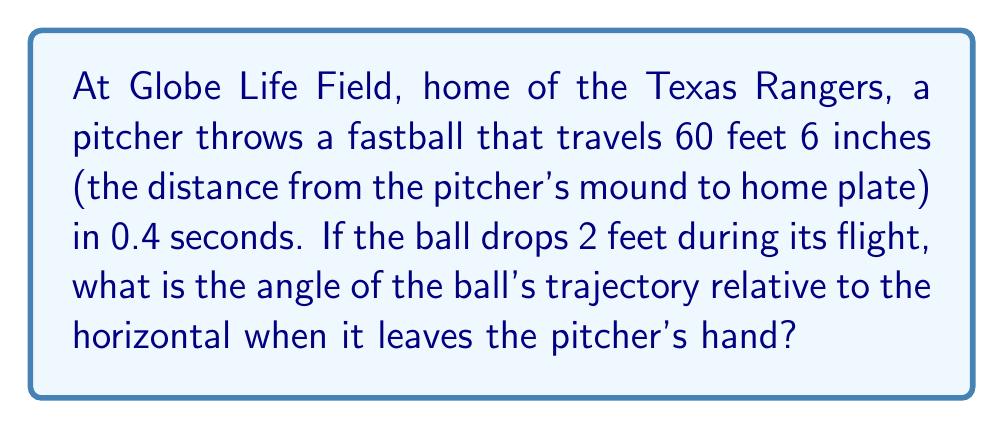Give your solution to this math problem. Let's approach this step-by-step:

1) First, we need to set up our coordinate system. Let's use the horizontal distance as x and the vertical drop as y.

2) We know:
   - Horizontal distance (x) = 60.5 feet
   - Time (t) = 0.4 seconds
   - Vertical drop (y) = 2 feet

3) We can use the equation of motion for an object under constant acceleration:

   $$y = y_0 + v_0y * t - \frac{1}{2}gt^2$$

   Where:
   $y_0$ is the initial height (0 in this case)
   $v_0y$ is the initial vertical velocity
   $g$ is the acceleration due to gravity (32 ft/s^2)

4) Substituting our values:

   $$-2 = 0 + v_0y * 0.4 - \frac{1}{2} * 32 * 0.4^2$$

5) Simplify:

   $$-2 = 0.4v_0y - 2.56$$

6) Solve for $v_0y$:

   $$0.4v_0y = 0.56$$
   $$v_0y = 1.4 \text{ ft/s}$$

7) Now we know the vertical component of the initial velocity. For the horizontal component:

   $$v_0x = \frac{60.5 \text{ ft}}{0.4 \text{ s}} = 151.25 \text{ ft/s}$$

8) The angle θ can be found using:

   $$\tan(\theta) = \frac{v_0y}{v_0x} = \frac{1.4}{151.25}$$

9) Taking the inverse tangent:

   $$\theta = \arctan(\frac{1.4}{151.25}) \approx 0.53°$$

[asy]
import geometry;

size(200);
pair O=(0,0), A=(10,0), B=(10,0.1);
draw(O--A--B--O);
label("θ", O, SW);
label("60.5 ft", (5,0), S);
label("2 ft", (10,0.05), E);
[/asy]
Answer: $0.53°$ 